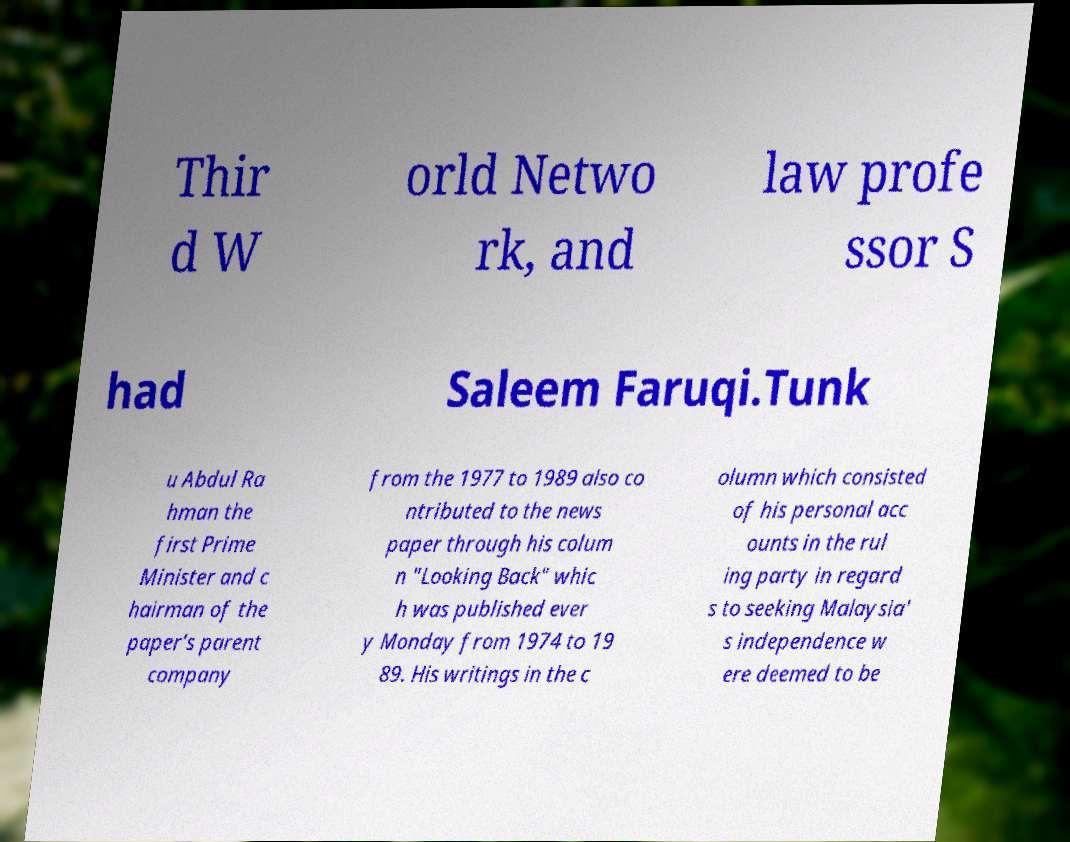For documentation purposes, I need the text within this image transcribed. Could you provide that? Thir d W orld Netwo rk, and law profe ssor S had Saleem Faruqi.Tunk u Abdul Ra hman the first Prime Minister and c hairman of the paper's parent company from the 1977 to 1989 also co ntributed to the news paper through his colum n "Looking Back" whic h was published ever y Monday from 1974 to 19 89. His writings in the c olumn which consisted of his personal acc ounts in the rul ing party in regard s to seeking Malaysia' s independence w ere deemed to be 